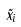Convert formula to latex. <formula><loc_0><loc_0><loc_500><loc_500>\tilde { x } _ { i }</formula> 